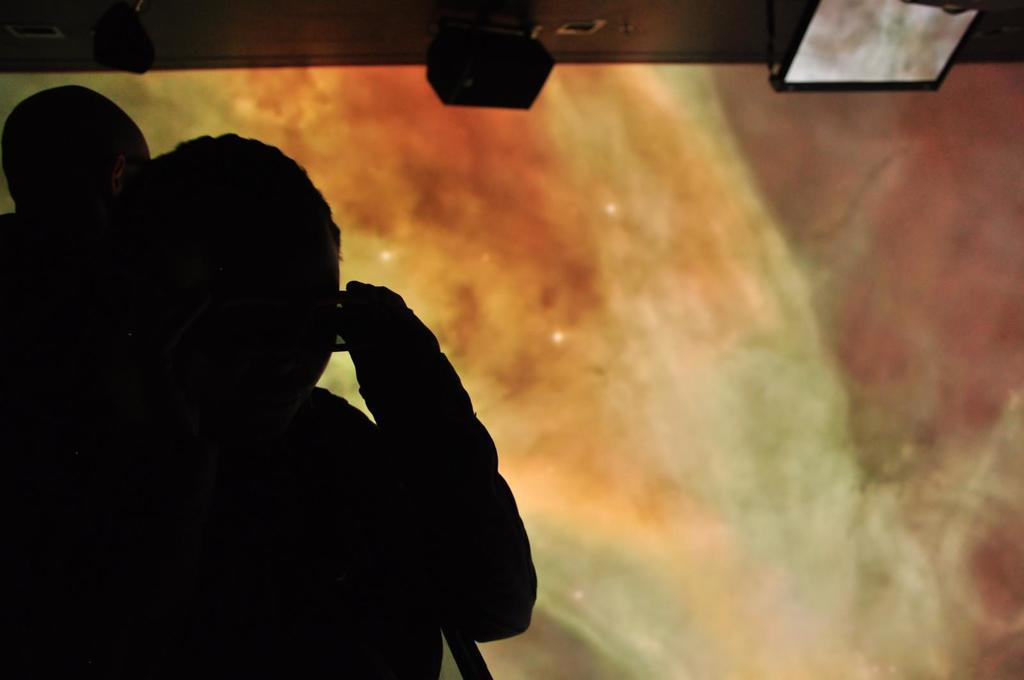How many clocks are on the moon in the image? There is no image provided, and therefore no information about clocks on the moon. 